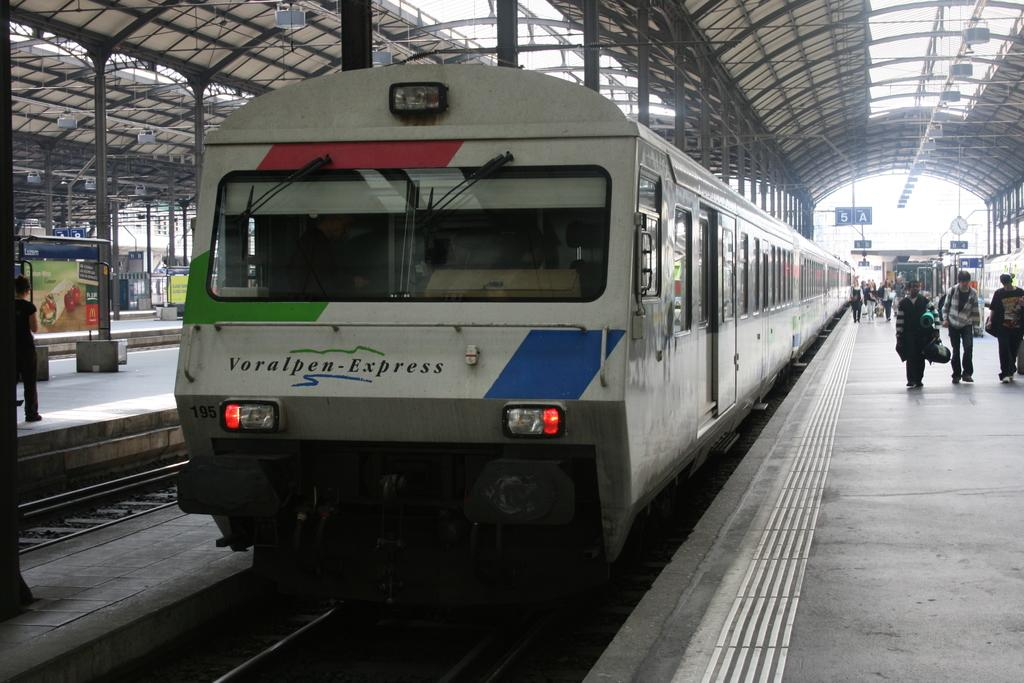Provide a one-sentence caption for the provided image. A blue, red and white train with 195 and voralpen express on front. 